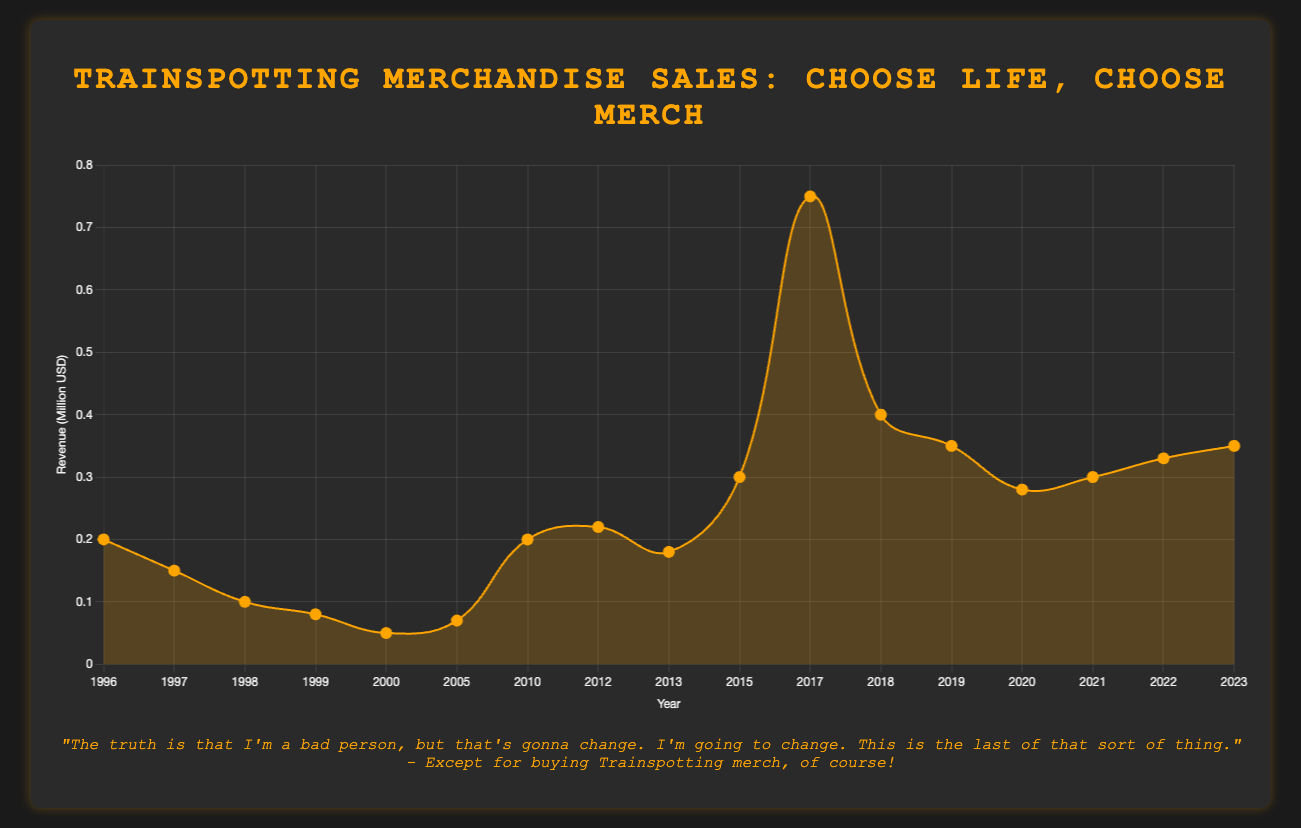What was the revenue in 1996 and what was the highlight event? The point for the year 1996 shows a revenue of 0.2 million USD, and the event highlighted is "Original Film Release".
Answer: 0.2 million USD, Original Film Release What was the peak revenue year and how much was it? The peak revenue can be identified by looking for the highest point on the graph which occurred in 2017 with a revenue of 0.75 million USD.
Answer: 2017, 0.75 million USD How did the revenue change between 2013 and 2015, and what events could have influenced this change? The revenue increased from 0.18 million USD in 2013 to 0.3 million USD in 2015, likely due to the "20-Year Anniversary Anticipation".
Answer: Increased by 0.12 million USD How did the year 2020 impact revenue compared to 2019? The revenue dropped from 0.35 million USD in 2019 to 0.28 million USD in 2020, probably due to "COVID-19 Impact".
Answer: Decreased by 0.07 million USD What are the three lowest revenue years and their respective amounts? By identifying the lowest points on the graph, the years and revenues are: 2000 (0.05 million USD), 1999 (0.08 million USD), and 1998 (0.1 million USD).
Answer: 2000 (0.05 million USD), 1999 (0.08 million USD), 1998 (0.1 million USD) Which year experienced the highest revenue increase and by how much? The year with the highest increase can be observed between 2015 (0.3 million USD) and 2017 (0.75 million USD), with an increase of 0.45 million USD.
Answer: 2017, increased by 0.45 million USD How does the 2017 revenue compare to the combined revenue of 1996, 1997, and 1998? Summing revenues for 1996 (0.2 million USD), 1997 (0.15 million USD), and 1998 (0.1 million USD) gives 0.45 million USD, which is less than 2017's revenue of 0.75 million USD.
Answer: Higher by 0.3 million USD What was the revenue trend from 2000 to 2005? From 2000's revenue of 0.05 million USD, the revenue showed an increasing trend reaching 0.07 million USD by 2005.
Answer: Increasing trend, ending at 0.07 million USD On which occasions did the revenue jump above 0.2 million USD? The chart shows that the revenue jumped above 0.2 million USD in 1996, 2010, 2012, 2015, 2017, 2018, 2019, 2021, 2022, and 2023.
Answer: 1996, 2010, 2012, 2015, 2017, 2018, 2019, 2021, 2022, 2023 What is the revenue trend from 2020 onward? From 2020's revenue of 0.28 million USD, there is a trend showing a gradual increase to 0.35 million USD in 2023.
Answer: Slightly increasing trend 